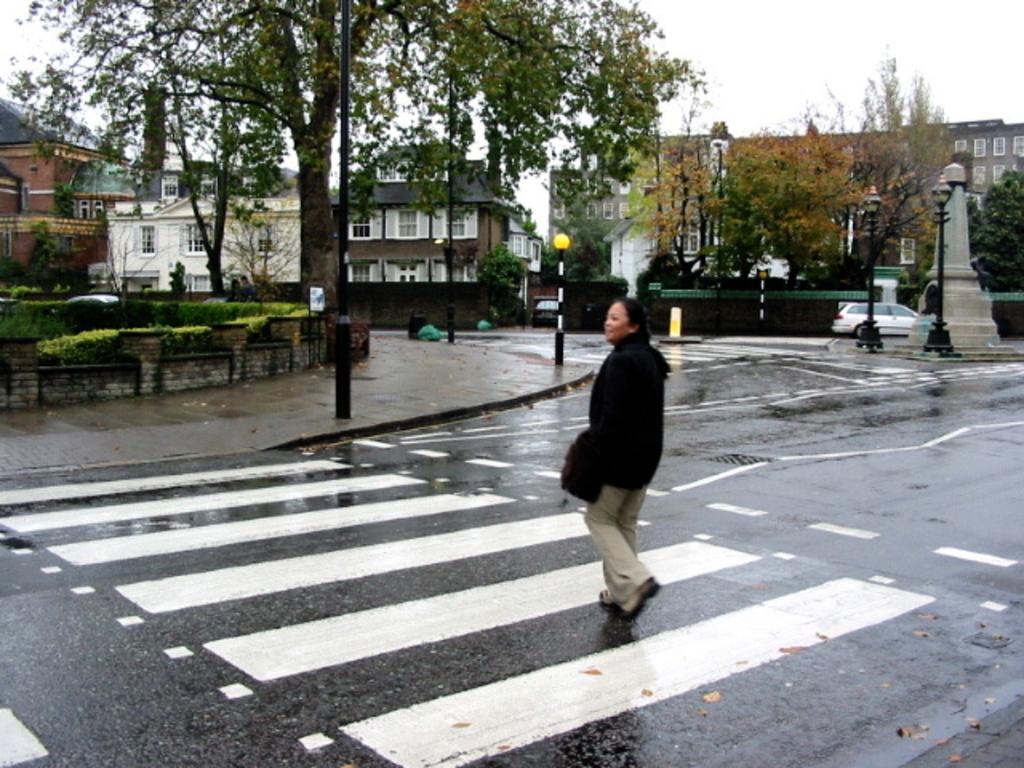How would you summarize this image in a sentence or two? In the center of the image there is a lady walking on the road. In the background of the image there are buildings, trees. At the top of the image there is sky. 